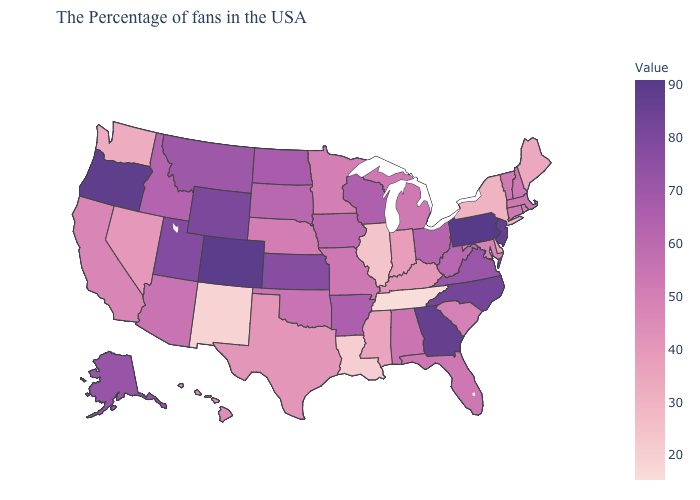Does Montana have the lowest value in the USA?
Short answer required. No. Which states hav the highest value in the MidWest?
Keep it brief. Kansas. Does the map have missing data?
Answer briefly. No. Does Colorado have the highest value in the West?
Short answer required. Yes. Among the states that border Vermont , which have the lowest value?
Write a very short answer. New York. 